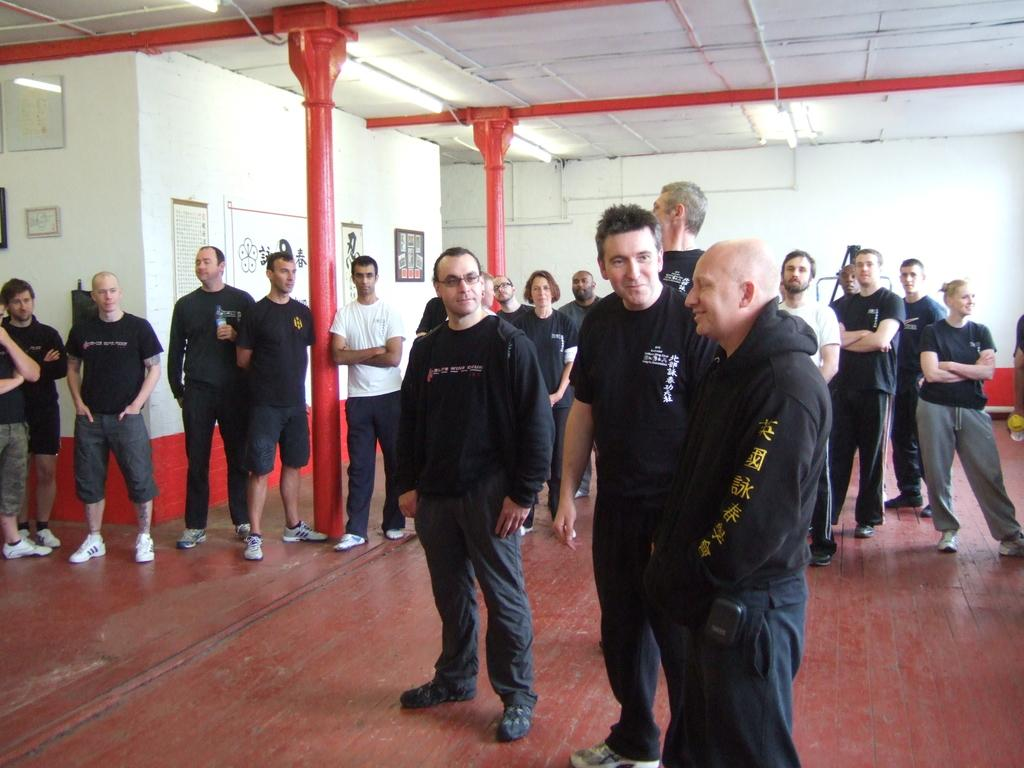What is happening in the hall according to the image? There are many people standing in the hall. What can be seen on the walls in the image? There are paintings and hangings on the wall. What color are most of the people wearing in the image? Most people are wearing black dress. What architectural feature stands out in the image? There are red pillars in the room. Can you hear the harmony of the bursting dock in the image? There is no mention of a dock or any sound in the image, so it's not possible to hear a harmony of a bursting dock. 